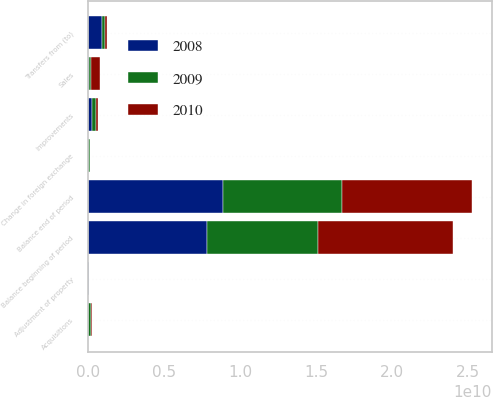<chart> <loc_0><loc_0><loc_500><loc_500><stacked_bar_chart><ecel><fcel>Balance beginning of period<fcel>Acquisitions<fcel>Improvements<fcel>Transfers from (to)<fcel>Sales<fcel>Adjustment of property<fcel>Change in foreign exchange<fcel>Balance end of period<nl><fcel>2010<fcel>8.88234e+09<fcel>8.38333e+07<fcel>1.15646e+08<fcel>1.15483e+08<fcel>6.03653e+08<fcel>1.76011e+07<fcel>3.62028e+07<fcel>8.59276e+09<nl><fcel>2008<fcel>7.81892e+09<fcel>7.13624e+06<fcel>2.24555e+08<fcel>9.33715e+08<fcel>4.88935e+07<fcel>5.21e+07<fcel>1.87926e+07<fcel>8.88234e+09<nl><fcel>2009<fcel>7.32503e+09<fcel>1.94097e+08<fcel>3.15921e+08<fcel>1.9458e+08<fcel>1.23943e+08<fcel>7.9e+06<fcel>7.33757e+07<fcel>7.81892e+09<nl></chart> 